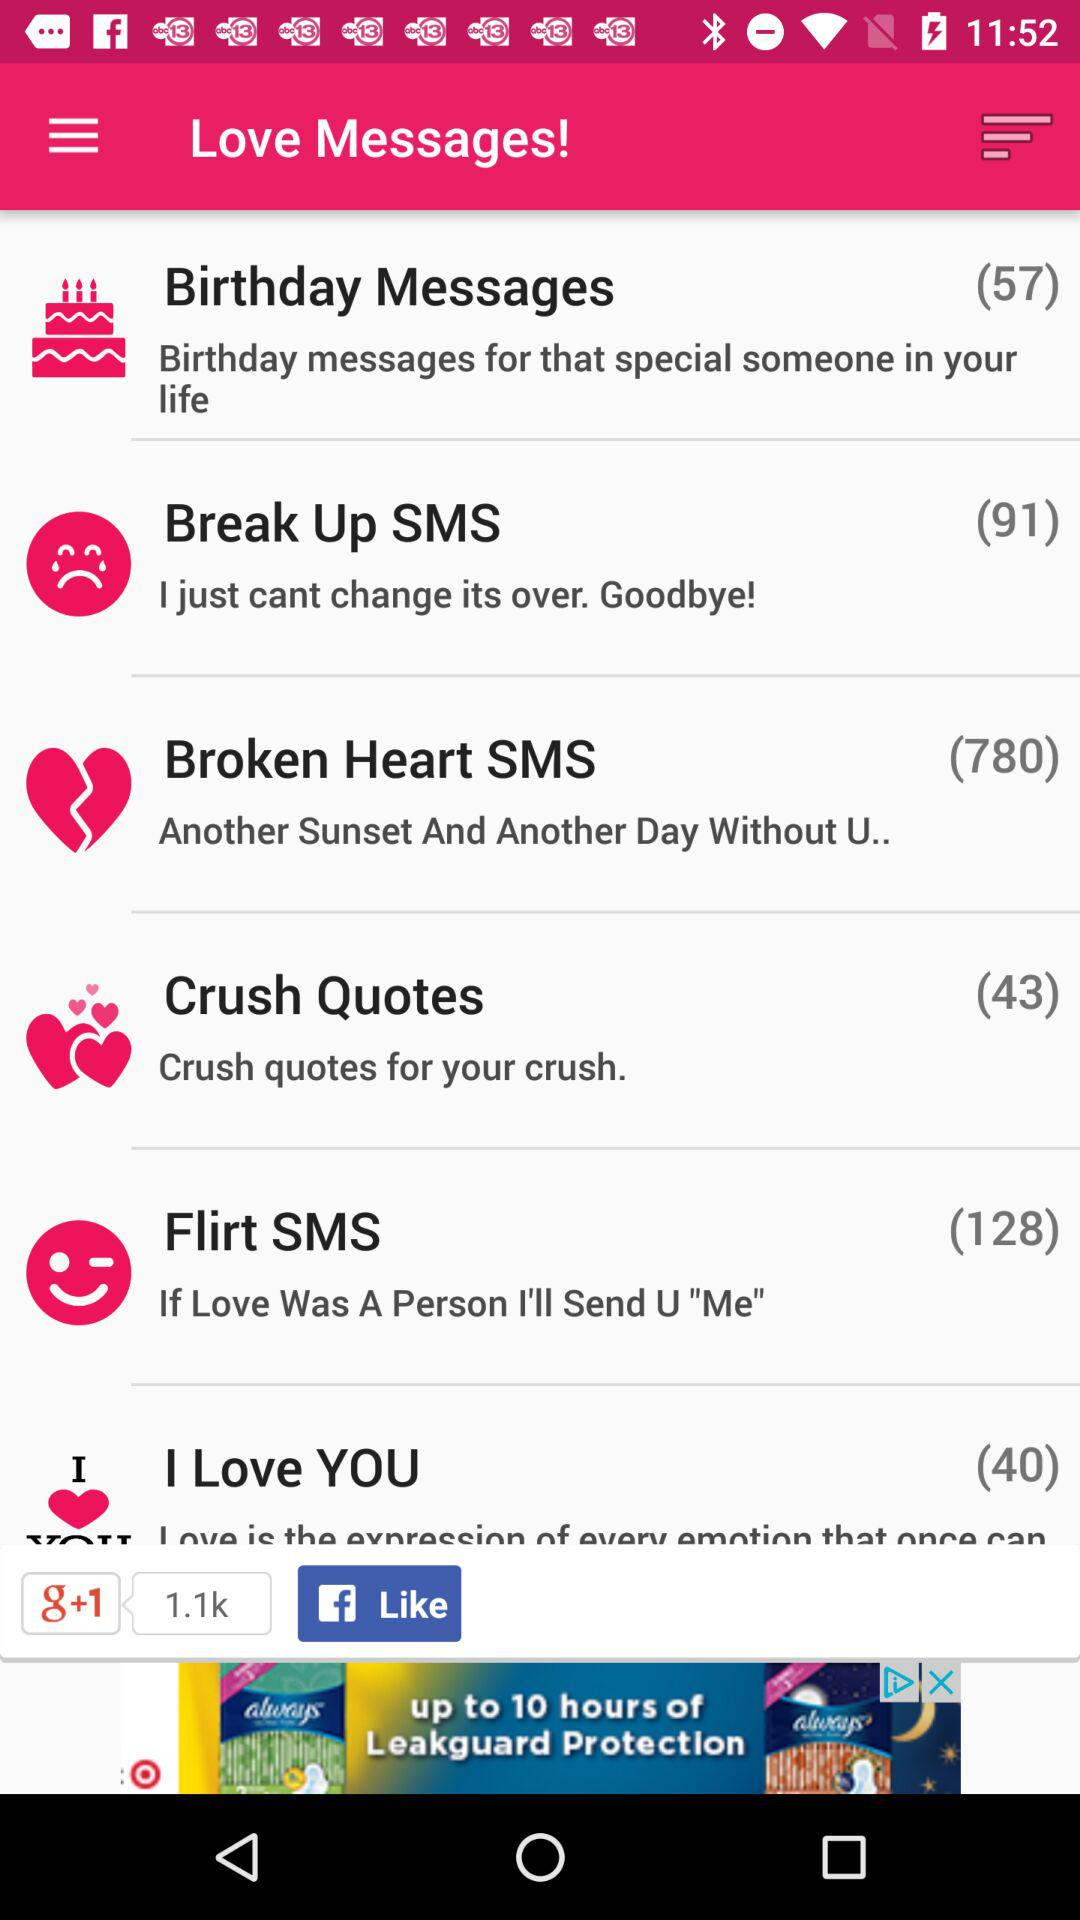How many messages are there in "Crush Quotes"? There are 43 messages in "Crush Quotes". 